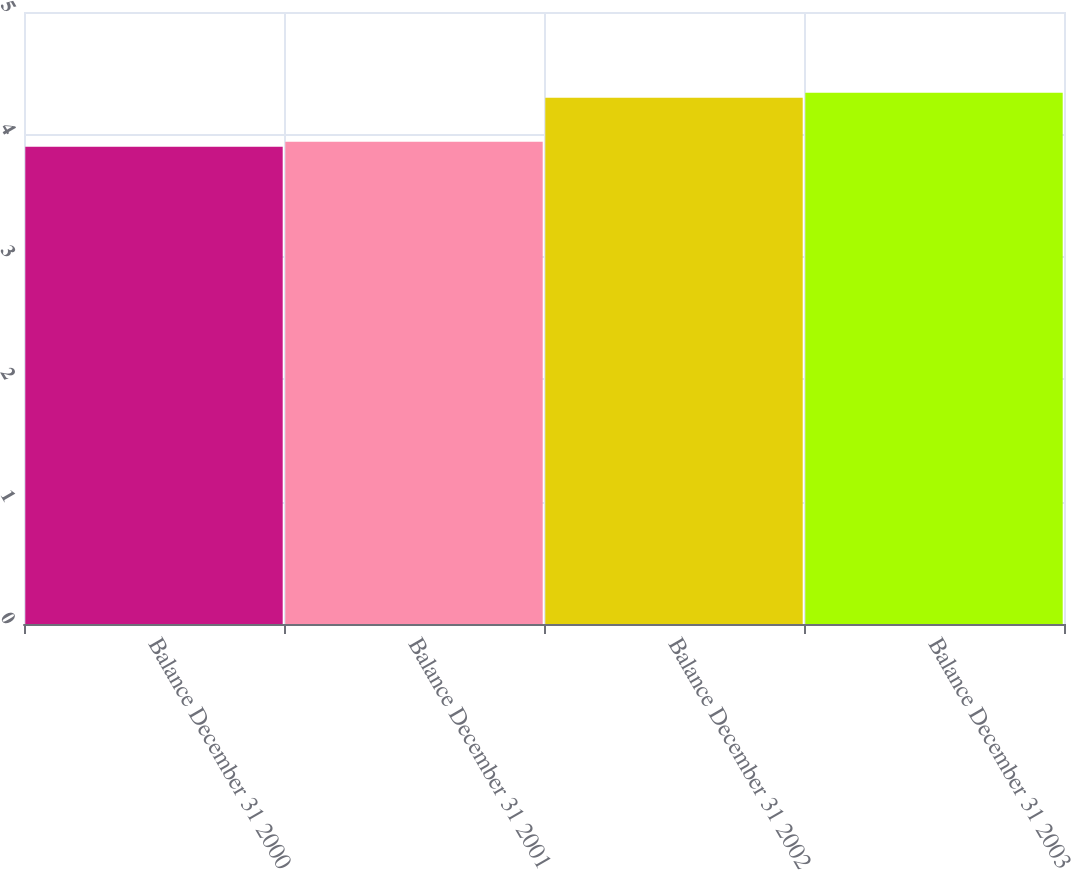Convert chart to OTSL. <chart><loc_0><loc_0><loc_500><loc_500><bar_chart><fcel>Balance December 31 2000<fcel>Balance December 31 2001<fcel>Balance December 31 2002<fcel>Balance December 31 2003<nl><fcel>3.9<fcel>3.94<fcel>4.3<fcel>4.34<nl></chart> 